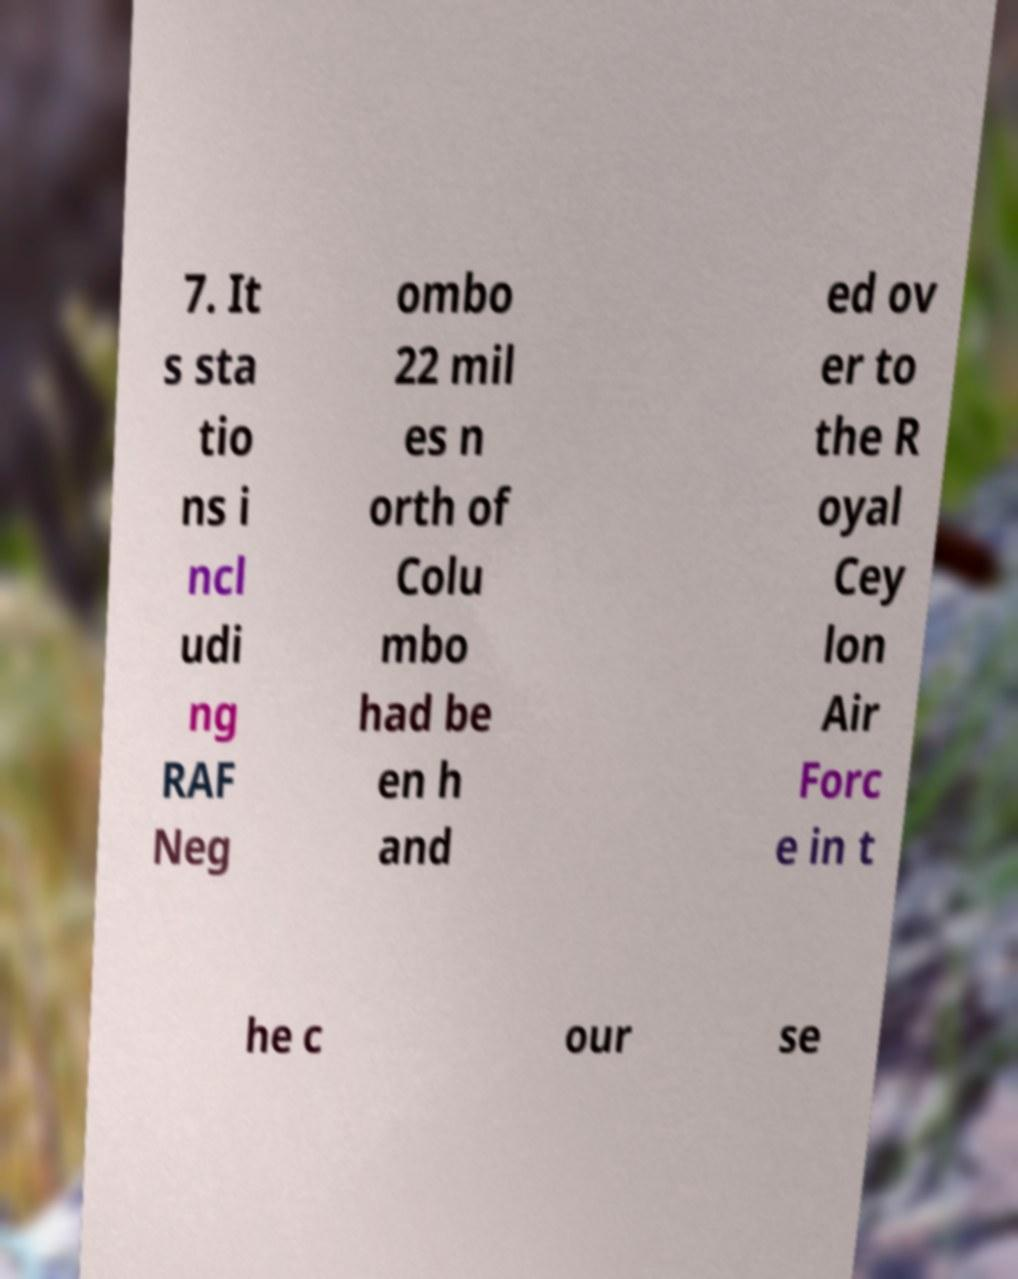I need the written content from this picture converted into text. Can you do that? 7. It s sta tio ns i ncl udi ng RAF Neg ombo 22 mil es n orth of Colu mbo had be en h and ed ov er to the R oyal Cey lon Air Forc e in t he c our se 